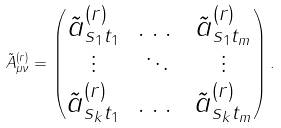<formula> <loc_0><loc_0><loc_500><loc_500>\tilde { A } _ { \mu \nu } ^ { ( r ) } = \begin{pmatrix} \tilde { a } ^ { ( r ) } _ { s _ { 1 } t _ { 1 } } & \dots & \tilde { a } ^ { ( r ) } _ { s _ { 1 } t _ { m } } \\ \vdots & \ddots & \vdots \\ \tilde { a } ^ { ( r ) } _ { s _ { k } t _ { 1 } } & \dots & \tilde { a } ^ { ( r ) } _ { s _ { k } t _ { m } } \end{pmatrix} .</formula> 